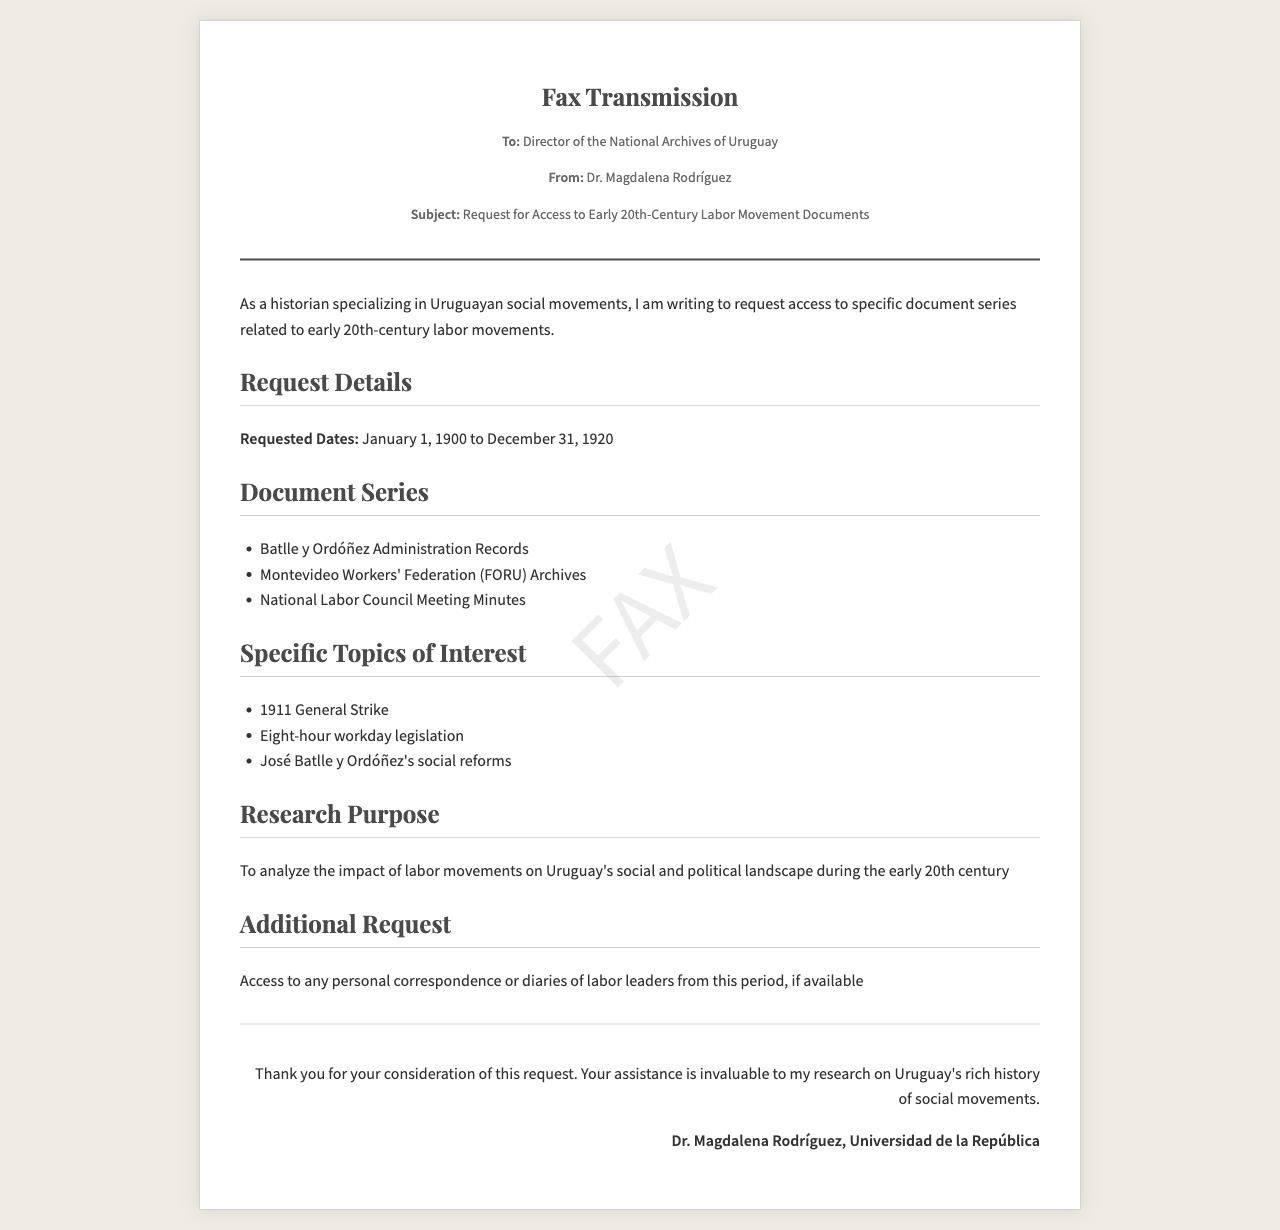What is the name of the sender? The sender is Dr. Magdalena Rodríguez, who is making the request.
Answer: Dr. Magdalena Rodríguez Who is the recipient of the fax? The fax is addressed to the Director of the National Archives of Uruguay.
Answer: Director of the National Archives of Uruguay What is the subject being requested? The subject of the fax is a request for access to early 20th-century labor movement documents.
Answer: Request for Access to Early 20th-Century Labor Movement Documents What are the requested dates for document access? The dates specified for access are from January 1, 1900 to December 31, 1920.
Answer: January 1, 1900 to December 31, 1920 Which administration's records are requested? The requested records include the Batlle y Ordóñez Administration Records.
Answer: Batlle y Ordóñez Administration Records What was the purpose of the research outlined in the document? The research aims to analyze the impact of labor movements on Uruguay's social and political landscape during the early 20th century.
Answer: To analyze the impact of labor movements on Uruguay's social and political landscape How many specific topics of interest are listed? There are three specific topics of interest mentioned in the fax.
Answer: Three What additional material is requested apart from the document series? Access to any personal correspondence or diaries of labor leaders from this period is also requested.
Answer: Personal correspondence or diaries of labor leaders What historical event is highlighted as a topic of interest? The 1911 General Strike is one of the highlighted topics of interest.
Answer: 1911 General Strike 